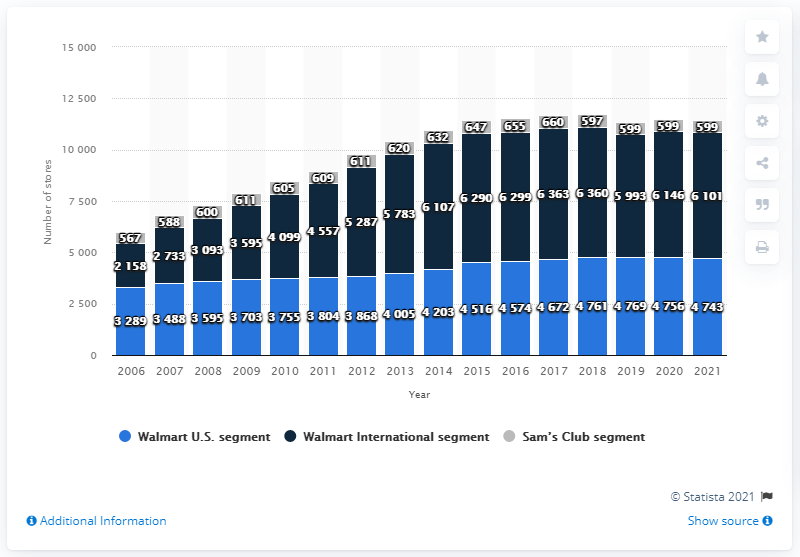Mention a couple of crucial points in this snapshot. As of January 31, 2021, Sam's Club operated a total of 599 stores. 